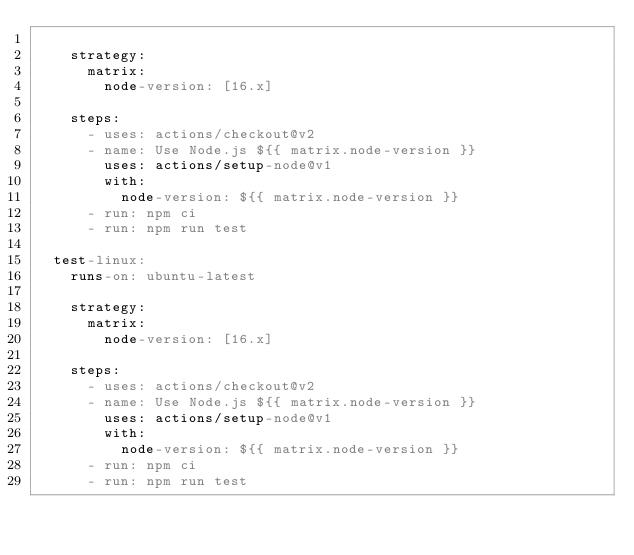Convert code to text. <code><loc_0><loc_0><loc_500><loc_500><_YAML_>
    strategy:
      matrix: 
        node-version: [16.x]
    
    steps:
      - uses: actions/checkout@v2
      - name: Use Node.js ${{ matrix.node-version }}
        uses: actions/setup-node@v1
        with: 
          node-version: ${{ matrix.node-version }}
      - run: npm ci
      - run: npm run test

  test-linux:
    runs-on: ubuntu-latest

    strategy:
      matrix: 
        node-version: [16.x]
    
    steps:
      - uses: actions/checkout@v2
      - name: Use Node.js ${{ matrix.node-version }}
        uses: actions/setup-node@v1
        with: 
          node-version: ${{ matrix.node-version }}
      - run: npm ci
      - run: npm run test</code> 